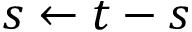Convert formula to latex. <formula><loc_0><loc_0><loc_500><loc_500>s \leftarrow t - s</formula> 